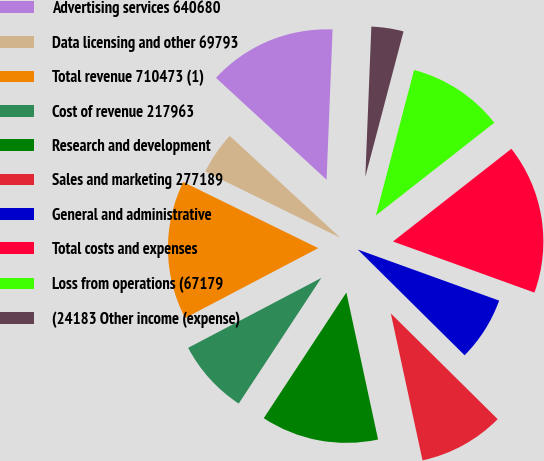Convert chart to OTSL. <chart><loc_0><loc_0><loc_500><loc_500><pie_chart><fcel>Advertising services 640680<fcel>Data licensing and other 69793<fcel>Total revenue 710473 (1)<fcel>Cost of revenue 217963<fcel>Research and development<fcel>Sales and marketing 277189<fcel>General and administrative<fcel>Total costs and expenses<fcel>Loss from operations (67179<fcel>(24183 Other income (expense)<nl><fcel>13.79%<fcel>4.6%<fcel>14.94%<fcel>8.05%<fcel>12.64%<fcel>9.2%<fcel>6.9%<fcel>16.09%<fcel>10.34%<fcel>3.45%<nl></chart> 